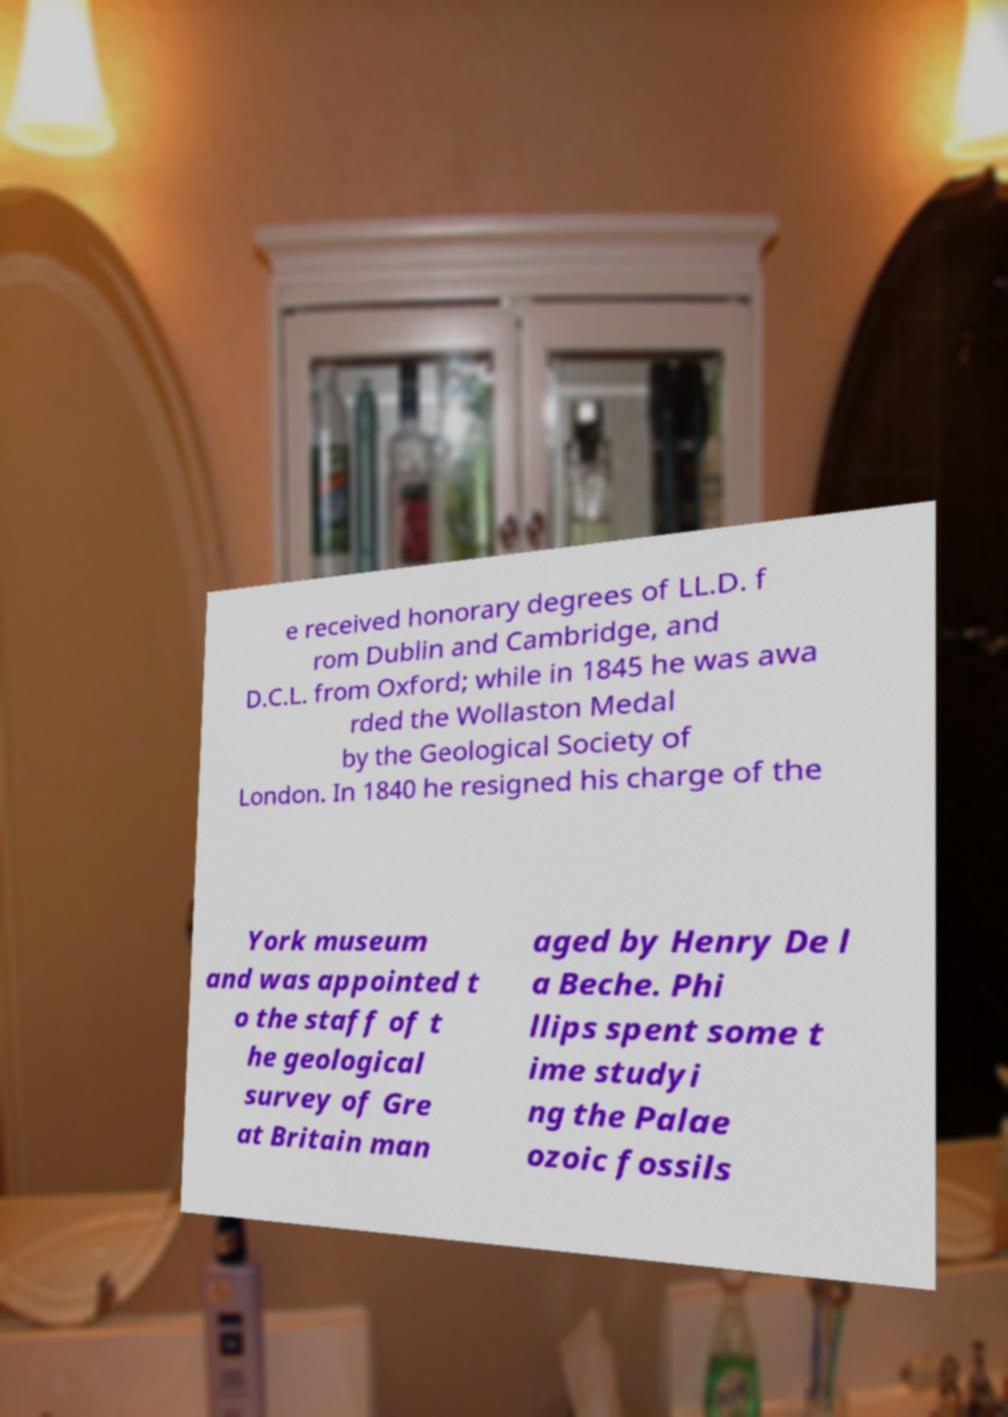Can you read and provide the text displayed in the image?This photo seems to have some interesting text. Can you extract and type it out for me? e received honorary degrees of LL.D. f rom Dublin and Cambridge, and D.C.L. from Oxford; while in 1845 he was awa rded the Wollaston Medal by the Geological Society of London. In 1840 he resigned his charge of the York museum and was appointed t o the staff of t he geological survey of Gre at Britain man aged by Henry De l a Beche. Phi llips spent some t ime studyi ng the Palae ozoic fossils 